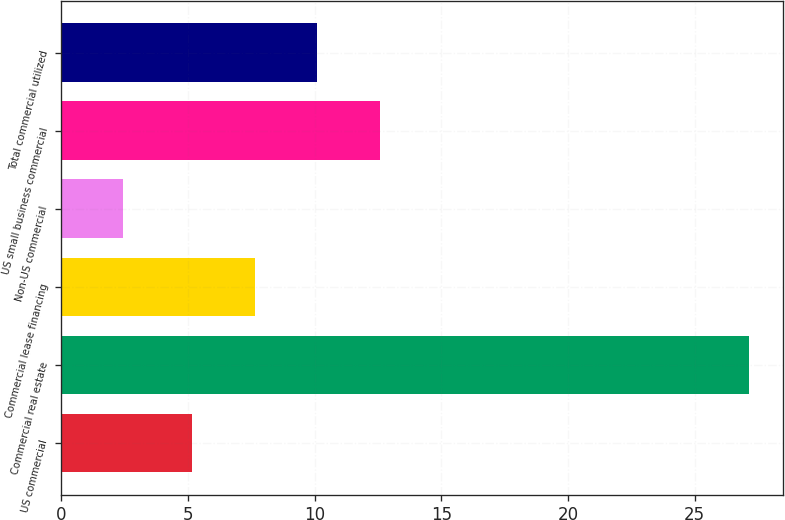Convert chart. <chart><loc_0><loc_0><loc_500><loc_500><bar_chart><fcel>US commercial<fcel>Commercial real estate<fcel>Commercial lease financing<fcel>Non-US commercial<fcel>US small business commercial<fcel>Total commercial utilized<nl><fcel>5.16<fcel>27.13<fcel>7.63<fcel>2.44<fcel>12.57<fcel>10.1<nl></chart> 